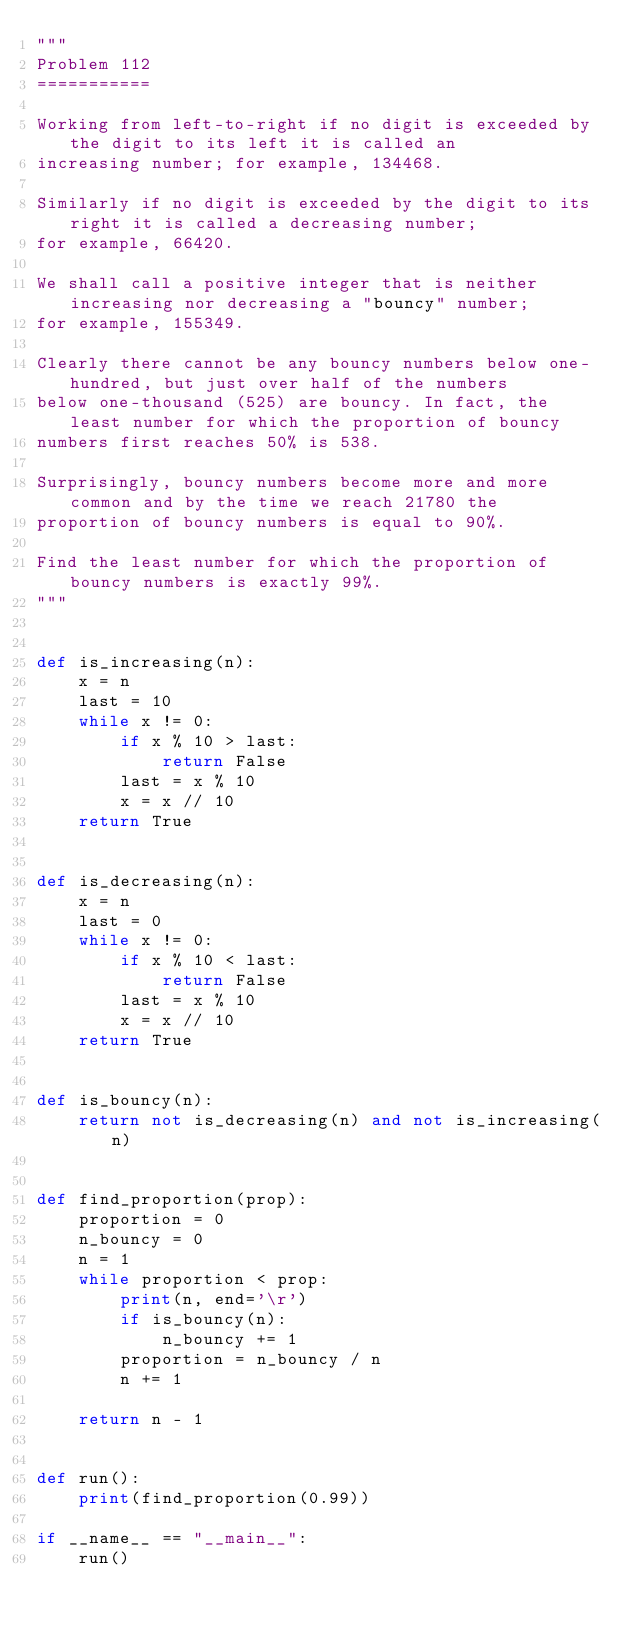Convert code to text. <code><loc_0><loc_0><loc_500><loc_500><_Python_>"""
Problem 112
===========

Working from left-to-right if no digit is exceeded by the digit to its left it is called an
increasing number; for example, 134468.

Similarly if no digit is exceeded by the digit to its right it is called a decreasing number;
for example, 66420.

We shall call a positive integer that is neither increasing nor decreasing a "bouncy" number;
for example, 155349.

Clearly there cannot be any bouncy numbers below one-hundred, but just over half of the numbers
below one-thousand (525) are bouncy. In fact, the least number for which the proportion of bouncy
numbers first reaches 50% is 538.

Surprisingly, bouncy numbers become more and more common and by the time we reach 21780 the
proportion of bouncy numbers is equal to 90%.

Find the least number for which the proportion of bouncy numbers is exactly 99%.
"""


def is_increasing(n):
    x = n
    last = 10
    while x != 0:
        if x % 10 > last:
            return False
        last = x % 10
        x = x // 10
    return True


def is_decreasing(n):
    x = n
    last = 0
    while x != 0:
        if x % 10 < last:
            return False
        last = x % 10
        x = x // 10
    return True


def is_bouncy(n):
    return not is_decreasing(n) and not is_increasing(n)


def find_proportion(prop):
    proportion = 0
    n_bouncy = 0
    n = 1
    while proportion < prop:
        print(n, end='\r')
        if is_bouncy(n):
            n_bouncy += 1
        proportion = n_bouncy / n
        n += 1

    return n - 1


def run():
    print(find_proportion(0.99))

if __name__ == "__main__":
    run()
</code> 